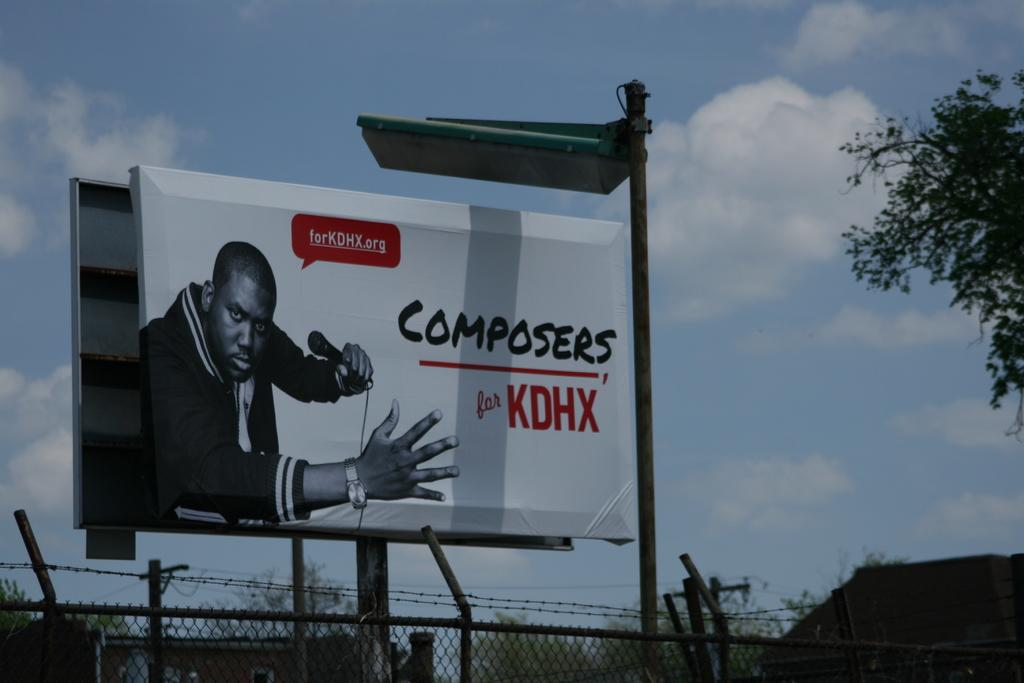What is hanging or displayed in the image? There is a banner in the image. What type of structure can be seen in the image? There is a fence in the image. What type of buildings are present in the image? There are sheds in the image. What type of vegetation is present in the image? There are trees in the image. What other objects can be seen in the image? There are some objects in the image. What can be seen in the background of the image? The sky with clouds is visible in the background of the image. What type of alarm is visible in the image? There is no alarm present in the image. What type of loaf can be seen in the image? There is no loaf present in the image. 